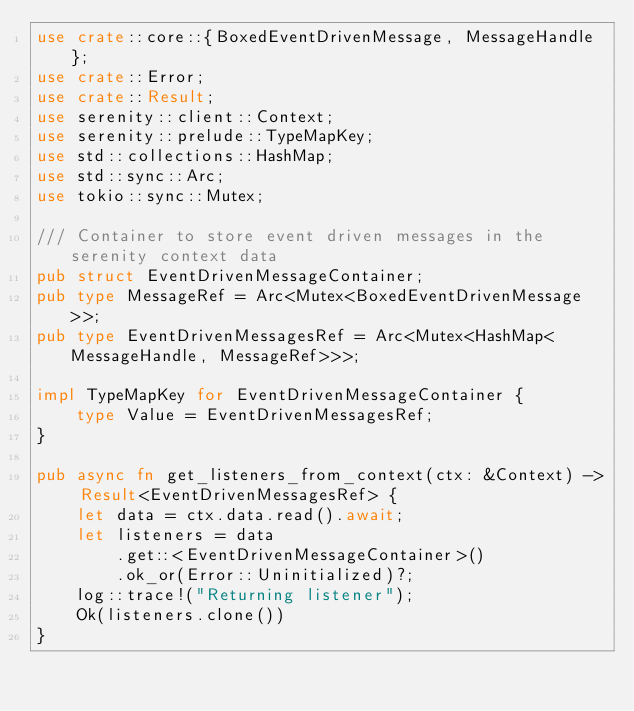<code> <loc_0><loc_0><loc_500><loc_500><_Rust_>use crate::core::{BoxedEventDrivenMessage, MessageHandle};
use crate::Error;
use crate::Result;
use serenity::client::Context;
use serenity::prelude::TypeMapKey;
use std::collections::HashMap;
use std::sync::Arc;
use tokio::sync::Mutex;

/// Container to store event driven messages in the serenity context data
pub struct EventDrivenMessageContainer;
pub type MessageRef = Arc<Mutex<BoxedEventDrivenMessage>>;
pub type EventDrivenMessagesRef = Arc<Mutex<HashMap<MessageHandle, MessageRef>>>;

impl TypeMapKey for EventDrivenMessageContainer {
    type Value = EventDrivenMessagesRef;
}

pub async fn get_listeners_from_context(ctx: &Context) -> Result<EventDrivenMessagesRef> {
    let data = ctx.data.read().await;
    let listeners = data
        .get::<EventDrivenMessageContainer>()
        .ok_or(Error::Uninitialized)?;
    log::trace!("Returning listener");
    Ok(listeners.clone())
}
</code> 